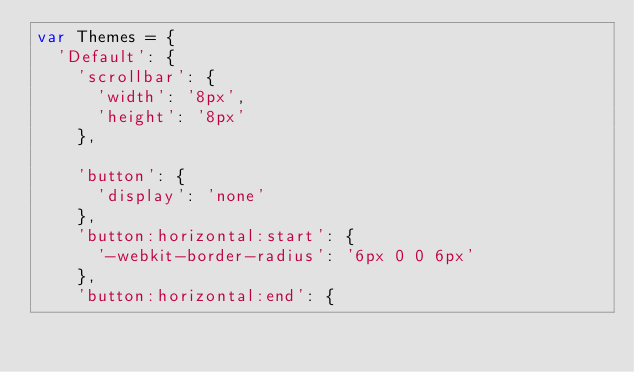Convert code to text. <code><loc_0><loc_0><loc_500><loc_500><_JavaScript_>var Themes = {
	'Default': {
		'scrollbar': {
			'width': '8px',
			'height': '8px'
		},
		
		'button': {
			'display': 'none'
		},
		'button:horizontal:start': {
			'-webkit-border-radius': '6px 0 0 6px'
		},
		'button:horizontal:end': {</code> 